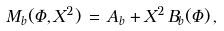<formula> <loc_0><loc_0><loc_500><loc_500>M _ { b } ( \Phi , X ^ { 2 } ) \, = \, A _ { b } + X ^ { 2 } \, B _ { b } ( \Phi ) \, ,</formula> 